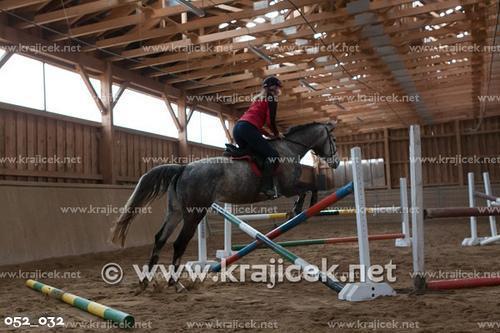How many horses are in the photo?
Give a very brief answer. 1. How many people are there?
Give a very brief answer. 1. 